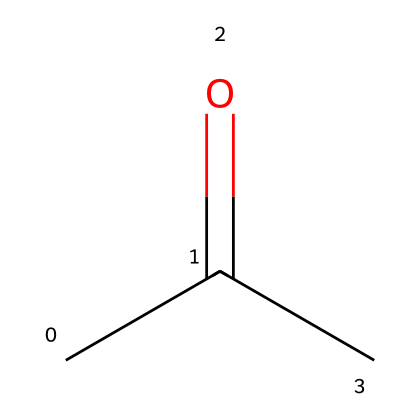What is the molecular formula of this chemical? The chemical structure provided is acetone, which has the SMILES representation CC(=O)C. To deduce the molecular formula, we count the carbon (C), hydrogen (H), and oxygen (O) atoms present. There are three carbon atoms, six hydrogen atoms, and one oxygen atom. Therefore, the molecular formula is C3H6O.
Answer: C3H6O How many carbon atoms are in this molecule? From the SMILES representation CC(=O)C, we can see there are three carbon atoms in total. Each 'C' in the representation depicts one carbon.
Answer: three What type of bonding is present between the carbon atoms? Examining the structure represented by the SMILES, we see there are single bonds between the carbon atoms in CC and a double bond to the oxygen in C(=O). This indicates that the carbon atoms are connected primarily through single covalent bonds, with one carbon involved in a double bond with oxygen.
Answer: single and double bonds Is acetone polar or non-polar? To determine the polarity of acetone, we need to look at the functional groups in the compound. The presence of the carbonyl group (C=O) introduces a dipole moment due to the electronegativity difference between carbon and oxygen. Therefore, acetone is polar.
Answer: polar What is the functional group present in acetone? In the given structure CC(=O)C, the carbonyl group (C=O) is identified as the characteristic functional group. This presence indicates that acetone is a ketone.
Answer: carbonyl group What is the primary use of this chemical in the context of personal grooming? Acetone is commonly known for its role as a solvent, particularly in nail polish remover. Its effectiveness in dissolving nail polish makes it a staple in personal grooming for manicures.
Answer: nail polish remover 